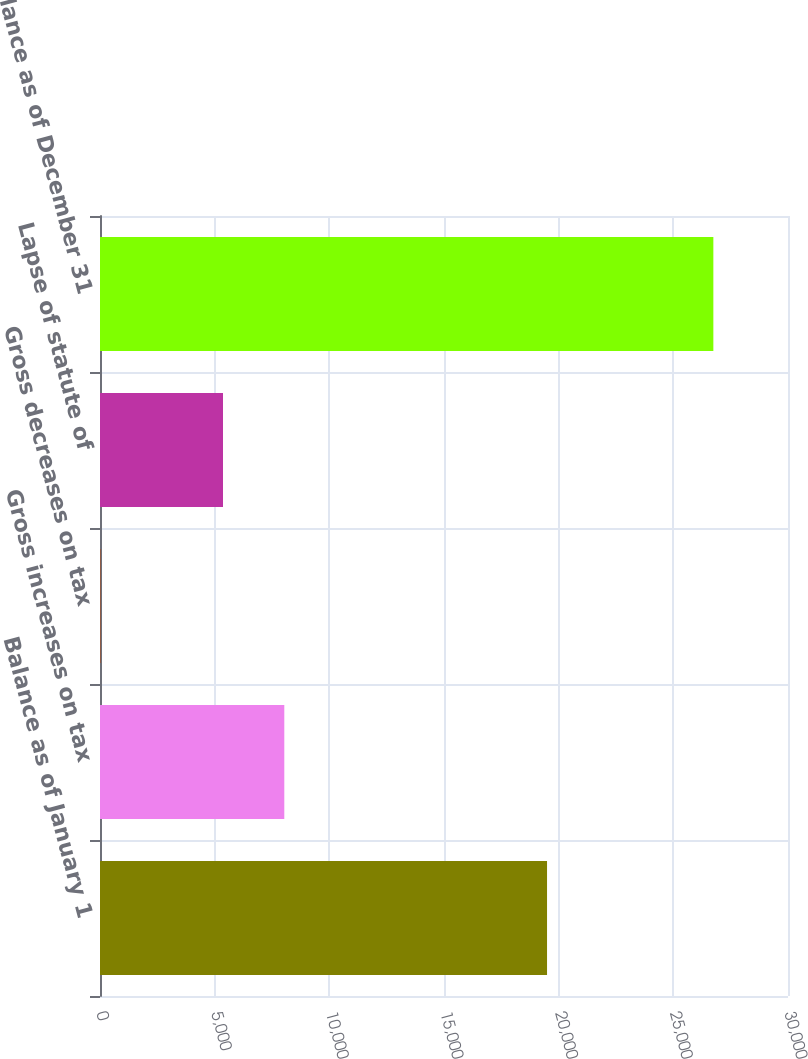Convert chart to OTSL. <chart><loc_0><loc_0><loc_500><loc_500><bar_chart><fcel>Balance as of January 1<fcel>Gross increases on tax<fcel>Gross decreases on tax<fcel>Lapse of statute of<fcel>Balance as of December 31<nl><fcel>19493<fcel>8036.1<fcel>18<fcel>5363.4<fcel>26745<nl></chart> 